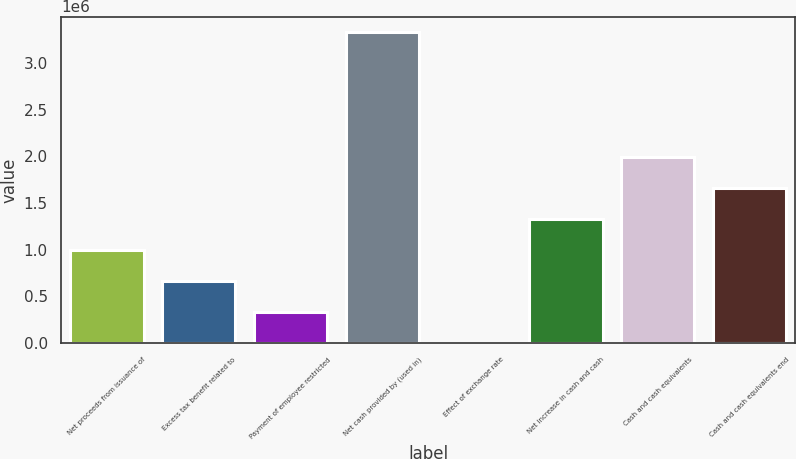Convert chart. <chart><loc_0><loc_0><loc_500><loc_500><bar_chart><fcel>Net proceeds from issuance of<fcel>Excess tax benefit related to<fcel>Payment of employee restricted<fcel>Net cash provided by (used in)<fcel>Effect of exchange rate<fcel>Net increase in cash and cash<fcel>Cash and cash equivalents<fcel>Cash and cash equivalents end<nl><fcel>998822<fcel>666069<fcel>333315<fcel>3.3281e+06<fcel>561<fcel>1.33158e+06<fcel>1.99708e+06<fcel>1.66433e+06<nl></chart> 